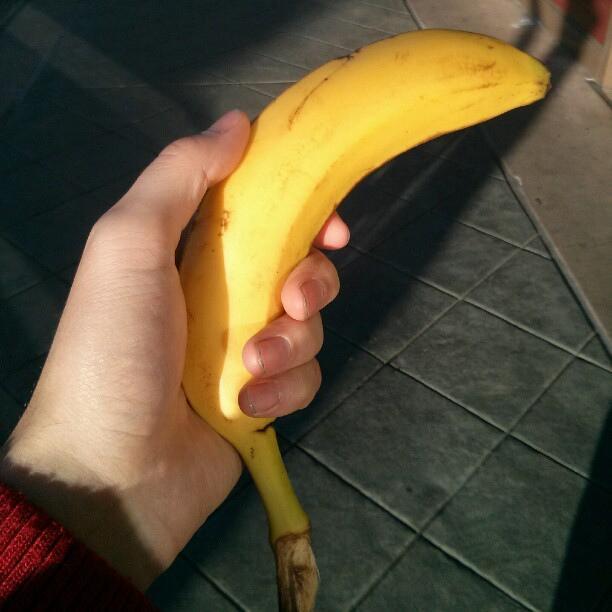Is "The banana is left of the person." an appropriate description for the image?
Answer yes or no. No. 